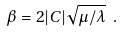<formula> <loc_0><loc_0><loc_500><loc_500>\beta = 2 | C | \sqrt { \mu / \lambda } \ .</formula> 